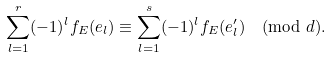<formula> <loc_0><loc_0><loc_500><loc_500>\sum _ { l = 1 } ^ { r } ( - 1 ) ^ { l } f _ { E } ( e _ { l } ) \equiv \sum _ { l = 1 } ^ { s } ( - 1 ) ^ { l } f _ { E } ( e ^ { \prime } _ { l } ) \pmod { d } .</formula> 